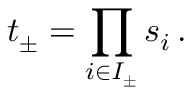Convert formula to latex. <formula><loc_0><loc_0><loc_500><loc_500>t _ { \pm } = \prod _ { i \in I _ { \pm } } s _ { i } \, .</formula> 